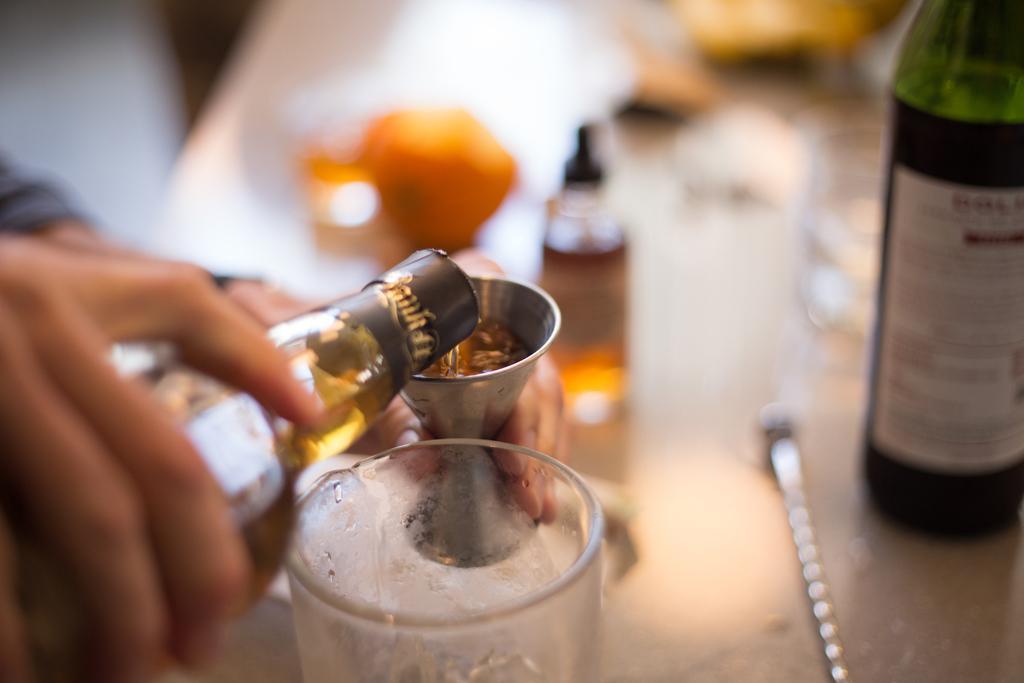Please provide a concise description of this image. In this image we can see hands of a person holding objects. Here we can see glasses, bottles, and other objects. There is a blur background. 